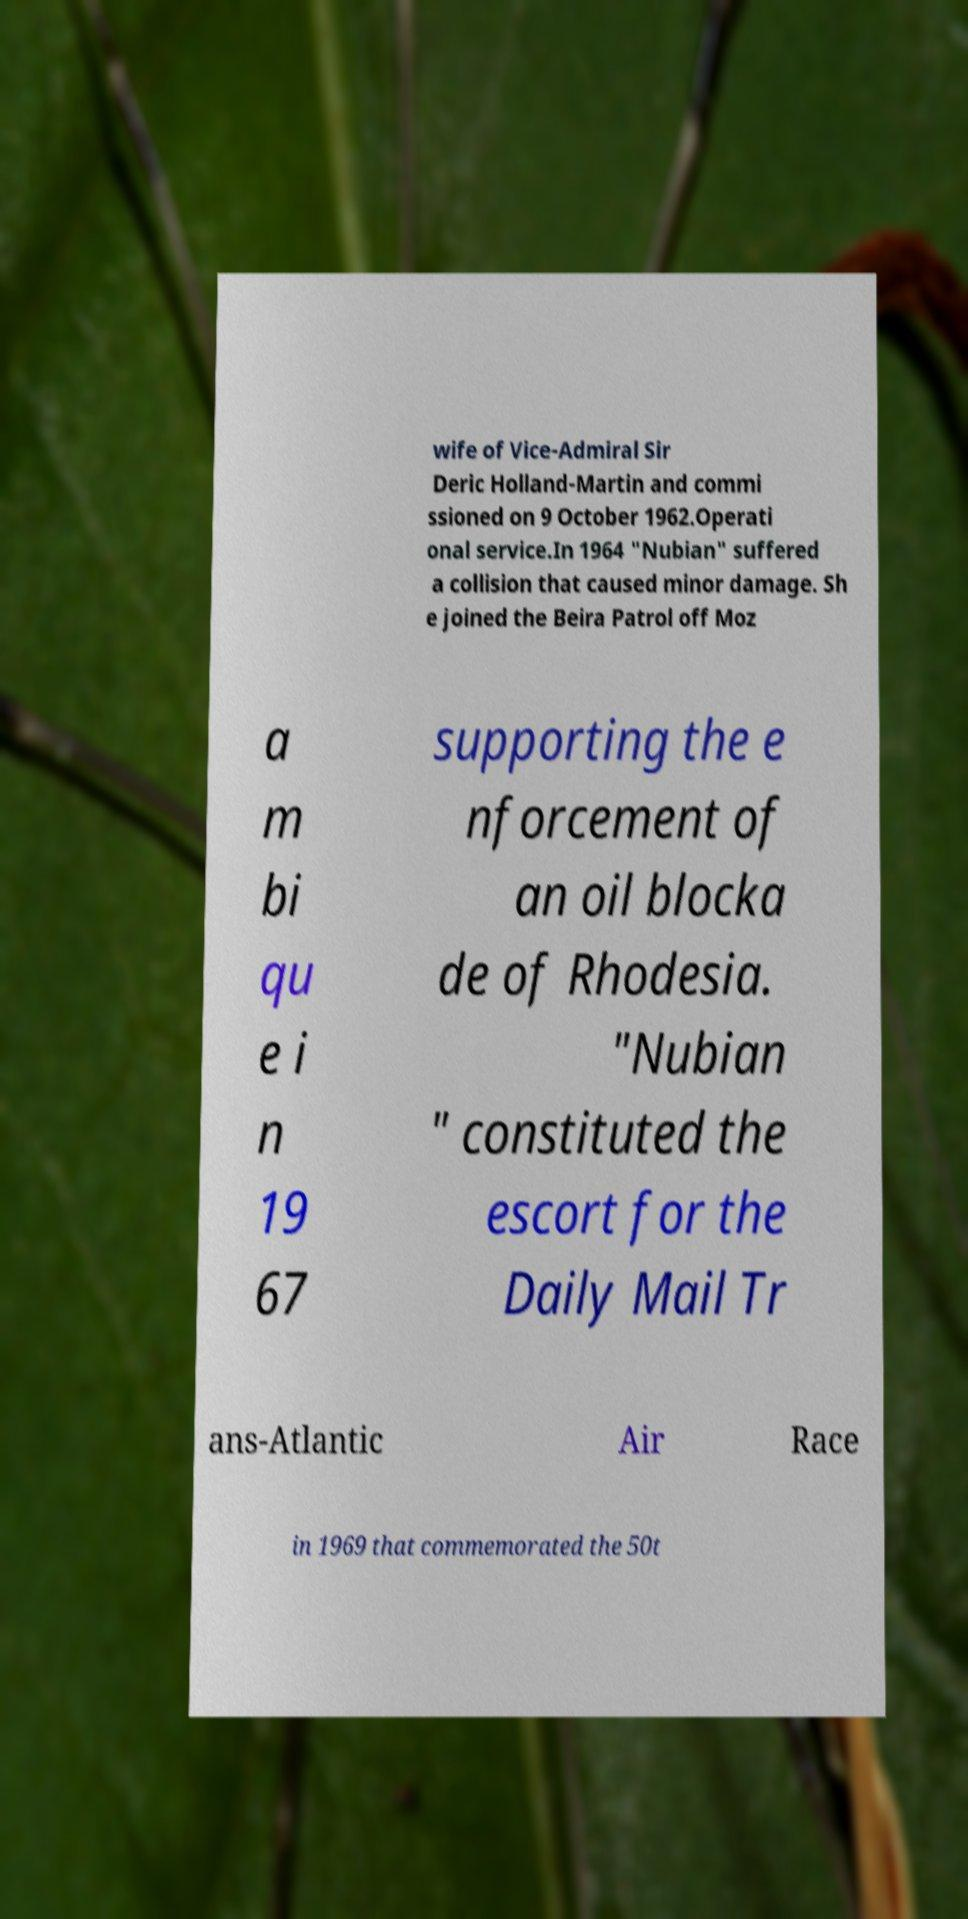There's text embedded in this image that I need extracted. Can you transcribe it verbatim? wife of Vice-Admiral Sir Deric Holland-Martin and commi ssioned on 9 October 1962.Operati onal service.In 1964 "Nubian" suffered a collision that caused minor damage. Sh e joined the Beira Patrol off Moz a m bi qu e i n 19 67 supporting the e nforcement of an oil blocka de of Rhodesia. "Nubian " constituted the escort for the Daily Mail Tr ans-Atlantic Air Race in 1969 that commemorated the 50t 